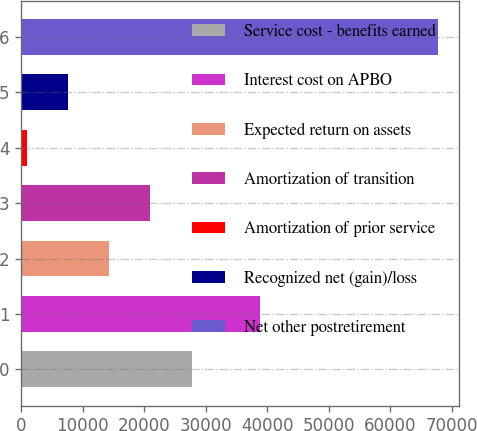Convert chart to OTSL. <chart><loc_0><loc_0><loc_500><loc_500><bar_chart><fcel>Service cost - benefits earned<fcel>Interest cost on APBO<fcel>Expected return on assets<fcel>Amortization of transition<fcel>Amortization of prior service<fcel>Recognized net (gain)/loss<fcel>Net other postretirement<nl><fcel>27722.4<fcel>38811<fcel>14357.2<fcel>21039.8<fcel>992<fcel>7674.6<fcel>67818<nl></chart> 